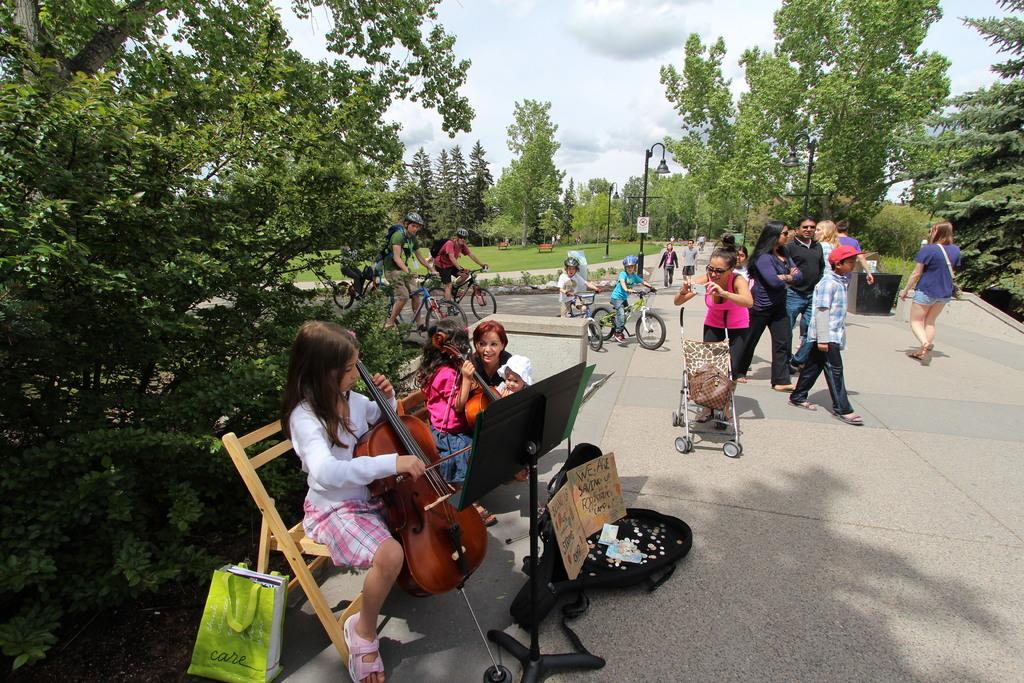What is happening in the image involving a group of people? There is a group of people in the image, and some of them are playing musical instruments. Where are the people located in the image? The people are on the road in the image. What can be seen in the background of the image? There are trees and the sky visible in the image. How much debt do the people in the image owe to the hand in the image? There is no hand or debt mentioned in the image; it only features a group of people on the road, some of whom are playing musical instruments. 